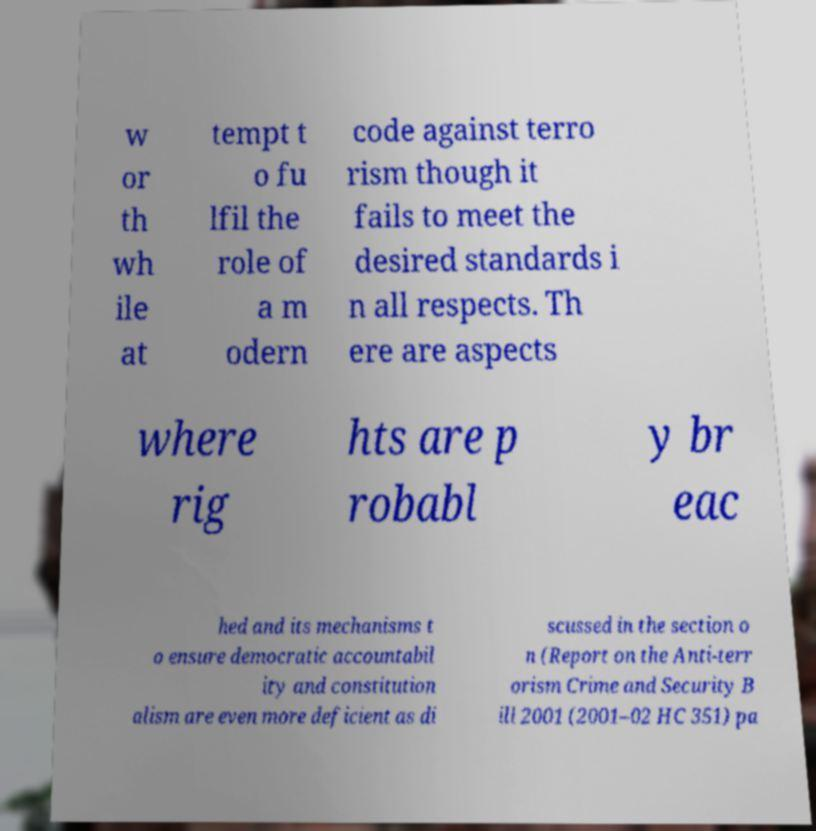Please identify and transcribe the text found in this image. w or th wh ile at tempt t o fu lfil the role of a m odern code against terro rism though it fails to meet the desired standards i n all respects. Th ere are aspects where rig hts are p robabl y br eac hed and its mechanisms t o ensure democratic accountabil ity and constitution alism are even more deficient as di scussed in the section o n (Report on the Anti-terr orism Crime and Security B ill 2001 (2001–02 HC 351) pa 